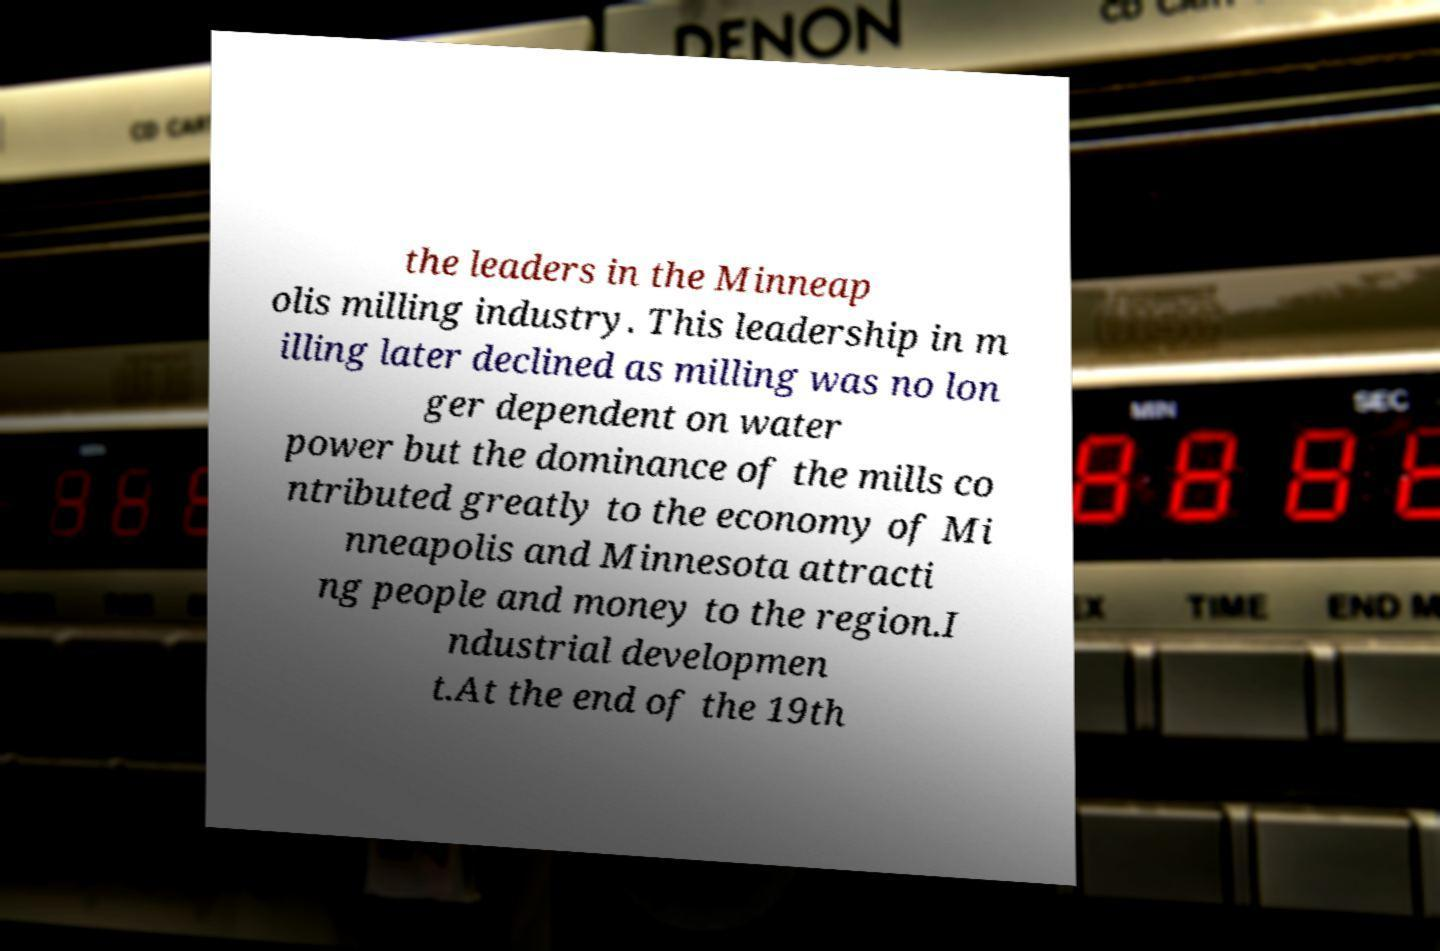I need the written content from this picture converted into text. Can you do that? the leaders in the Minneap olis milling industry. This leadership in m illing later declined as milling was no lon ger dependent on water power but the dominance of the mills co ntributed greatly to the economy of Mi nneapolis and Minnesota attracti ng people and money to the region.I ndustrial developmen t.At the end of the 19th 